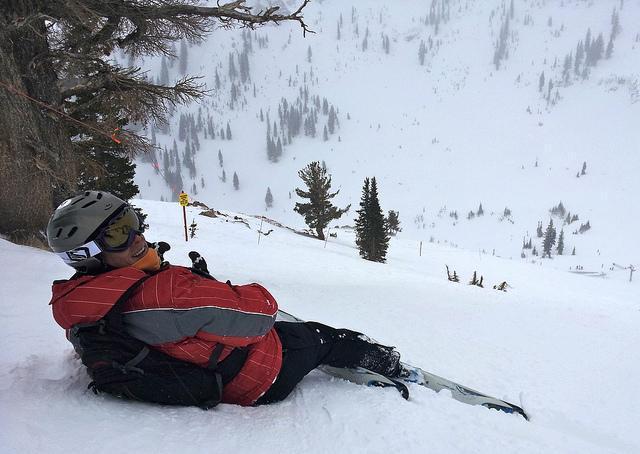How many people can be seen?
Give a very brief answer. 1. 